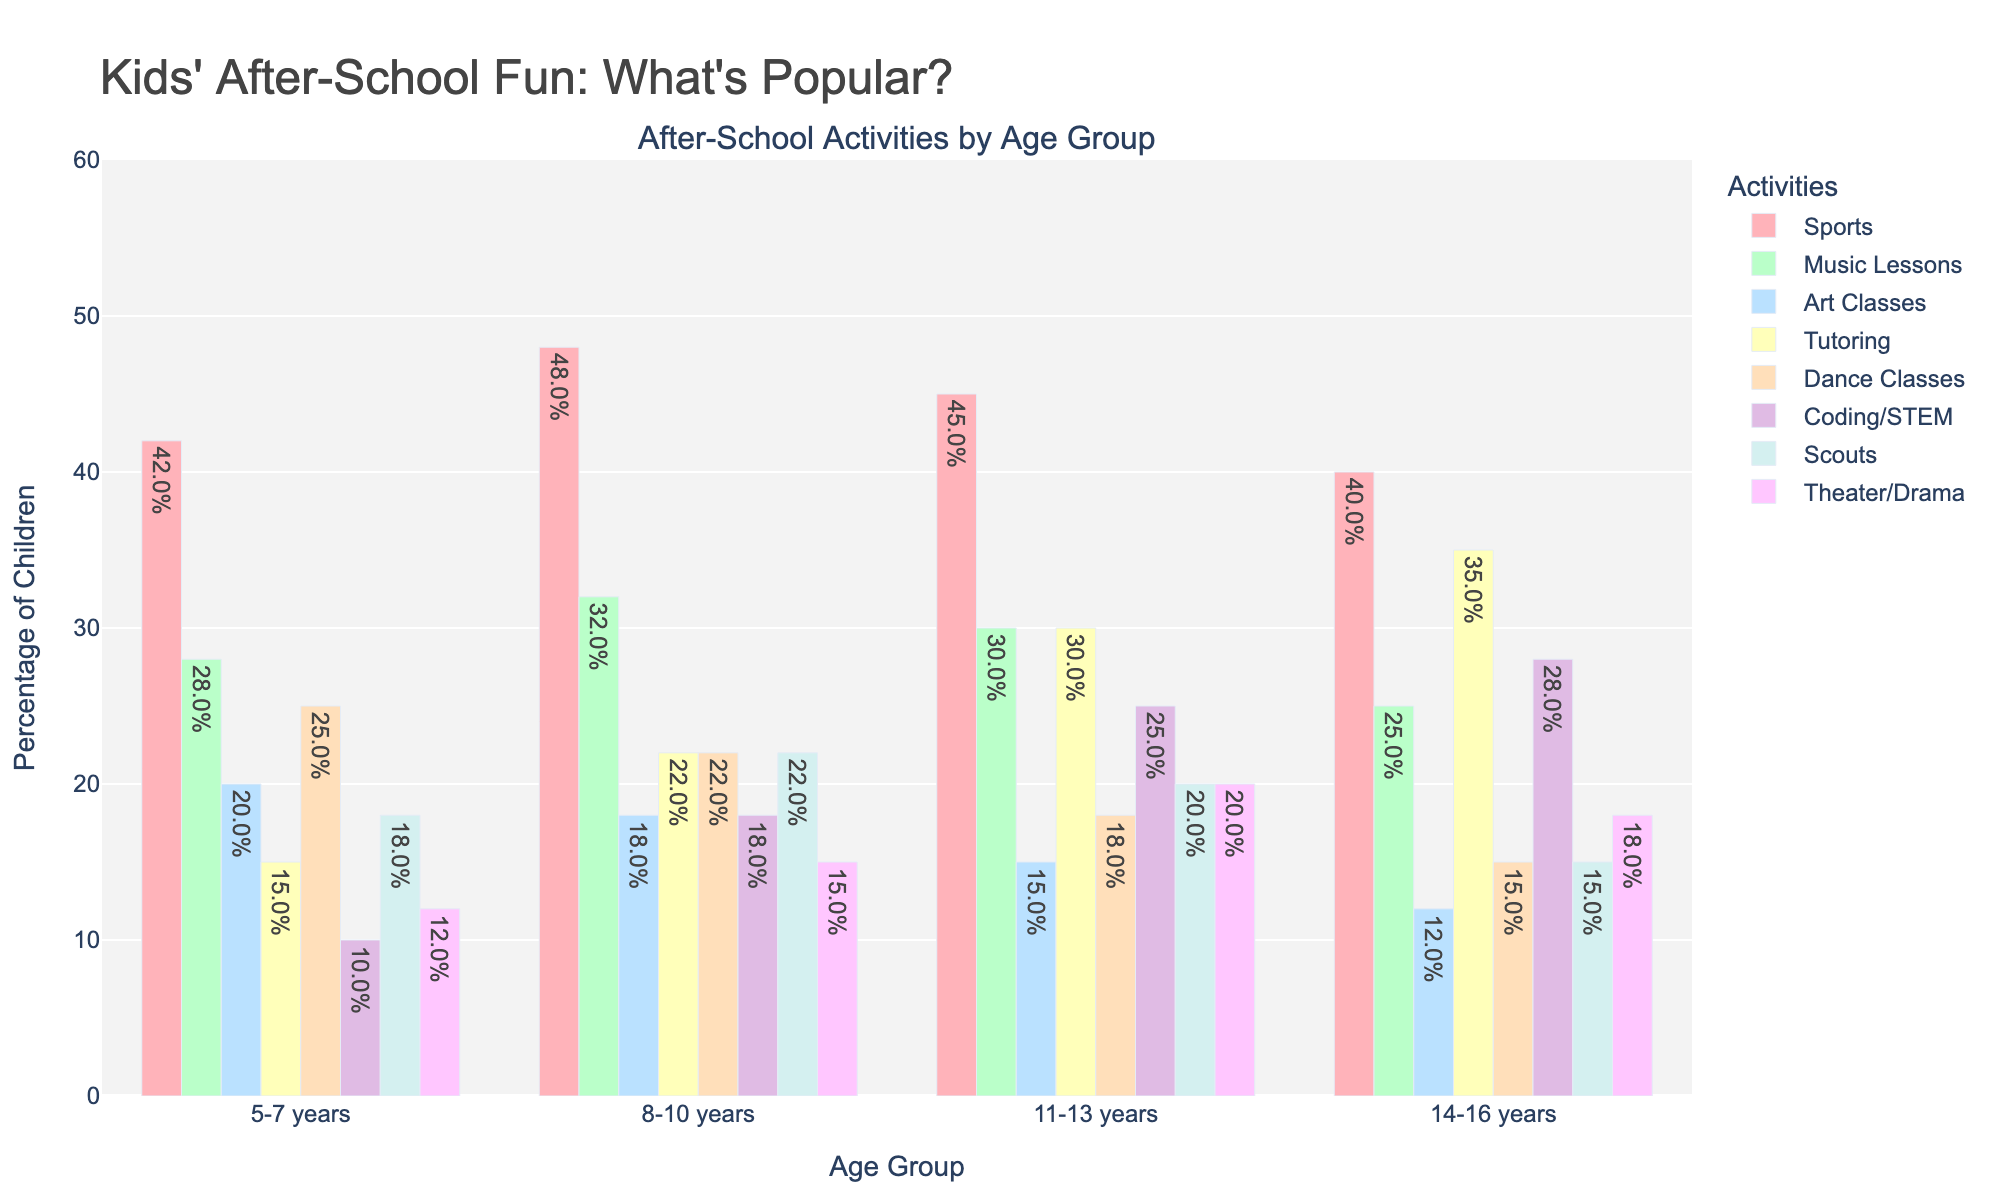Which after-school activity is the most popular for children aged 5-7 years? By looking at the colored bars corresponding to the age group 5-7 years, we see that the height of the bar for "Sports" is the tallest compared to other activities.
Answer: Sports How does the participation in Music Lessons change from the 5-7 years age group to the 14-16 years age group? Checking the height of the blue-colored bars for "Music Lessons," we observe a decrease from 28% in the 5-7 years age group to 25% in the 14-16 years age group.
Answer: It decreases Which age group has the highest participation in Tutoring? Comparing the bars for "Tutoring" across all age groups, we see the tallest bar is in the 14-16 years age group at 35%.
Answer: 14-16 years Between Art Classes and Coding/STEM, which activity has higher participation rates for children aged 11-13 years? For the 11-13 years age group, by comparing the corresponding bars, we see "Coding/STEM" has a bar height of 25% while "Art Classes" has a bar height of 15%.
Answer: Coding/STEM What is the combined percentage of participation in Dance Classes and Scouts for 8-10 years old children? The percentage for Dance Classes is 22% and for Scouts, it is 22% for the 8-10 age group. Adding them together gives 22% + 22% = 44%.
Answer: 44% What trend do you observe in participation in Sports as children grow older? The bars for "Sports" start at 42% for the 5-7 years age group, increase to 48% for the 8-10 years age group, then slightly decrease to 45% for the 11-13 years age group and further decrease to 40% for the 14-16 years age group.
Answer: Increases then decreases Which activity has the least participation among 14-16 years old children? By examining the height of all bars for the 14-16 years age group, we notice that "Art Classes" have the shortest bar at 12%.
Answer: Art Classes In which age group is participation in Theater/Drama the highest? Comparing the height of the bars for "Theater/Drama" across all age groups, we see that the tallest bar is in the 11-13 years age group at 20%.
Answer: 11-13 years 